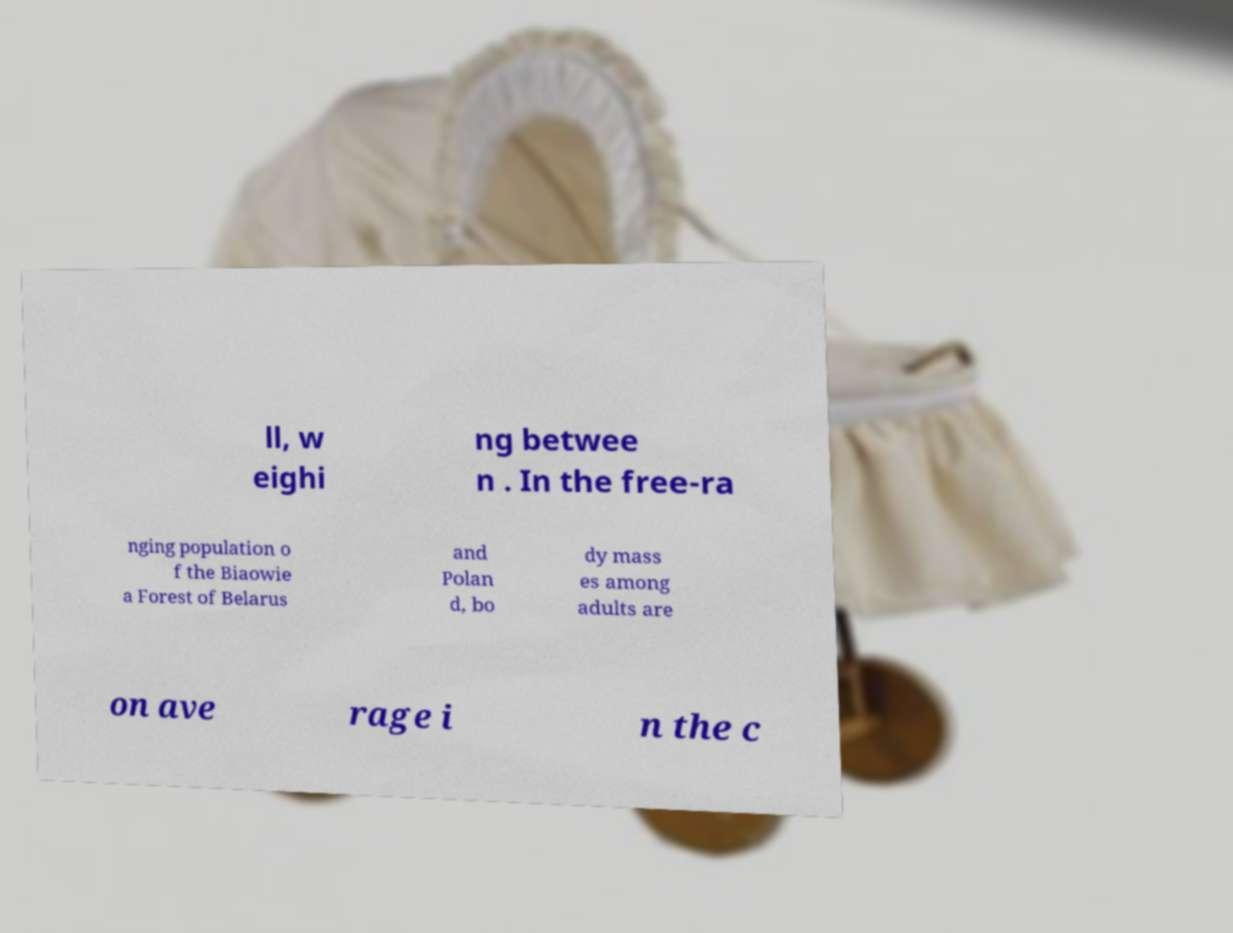Could you extract and type out the text from this image? ll, w eighi ng betwee n . In the free-ra nging population o f the Biaowie a Forest of Belarus and Polan d, bo dy mass es among adults are on ave rage i n the c 